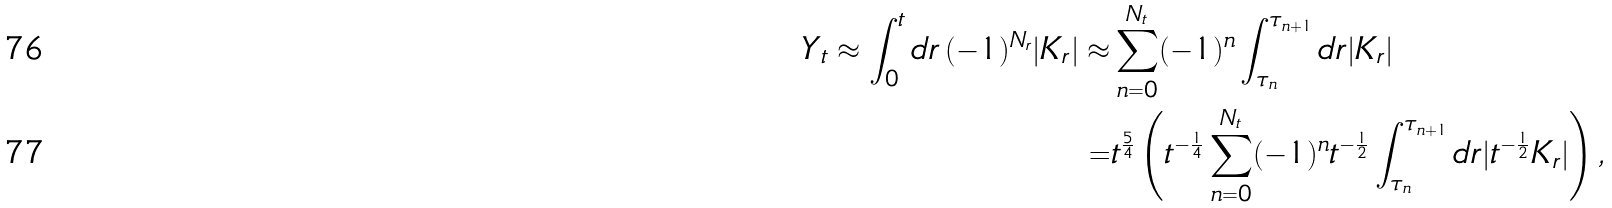Convert formula to latex. <formula><loc_0><loc_0><loc_500><loc_500>Y _ { t } \approx \int _ { 0 } ^ { t } d r \, ( - 1 ) ^ { N _ { r } } | K _ { r } | \approx & \sum _ { n = 0 } ^ { N _ { t } } ( - 1 ) ^ { n } \int _ { \tau _ { n } } ^ { \tau _ { n + 1 } } d r | K _ { r } | \\ = & t ^ { \frac { 5 } { 4 } } \left ( t ^ { - \frac { 1 } { 4 } } \sum _ { n = 0 } ^ { N _ { t } } ( - 1 ) ^ { n } t ^ { - \frac { 1 } { 2 } } \int _ { \tau _ { n } } ^ { \tau _ { n + 1 } } d r | t ^ { - \frac { 1 } { 2 } } K _ { r } | \right ) ,</formula> 